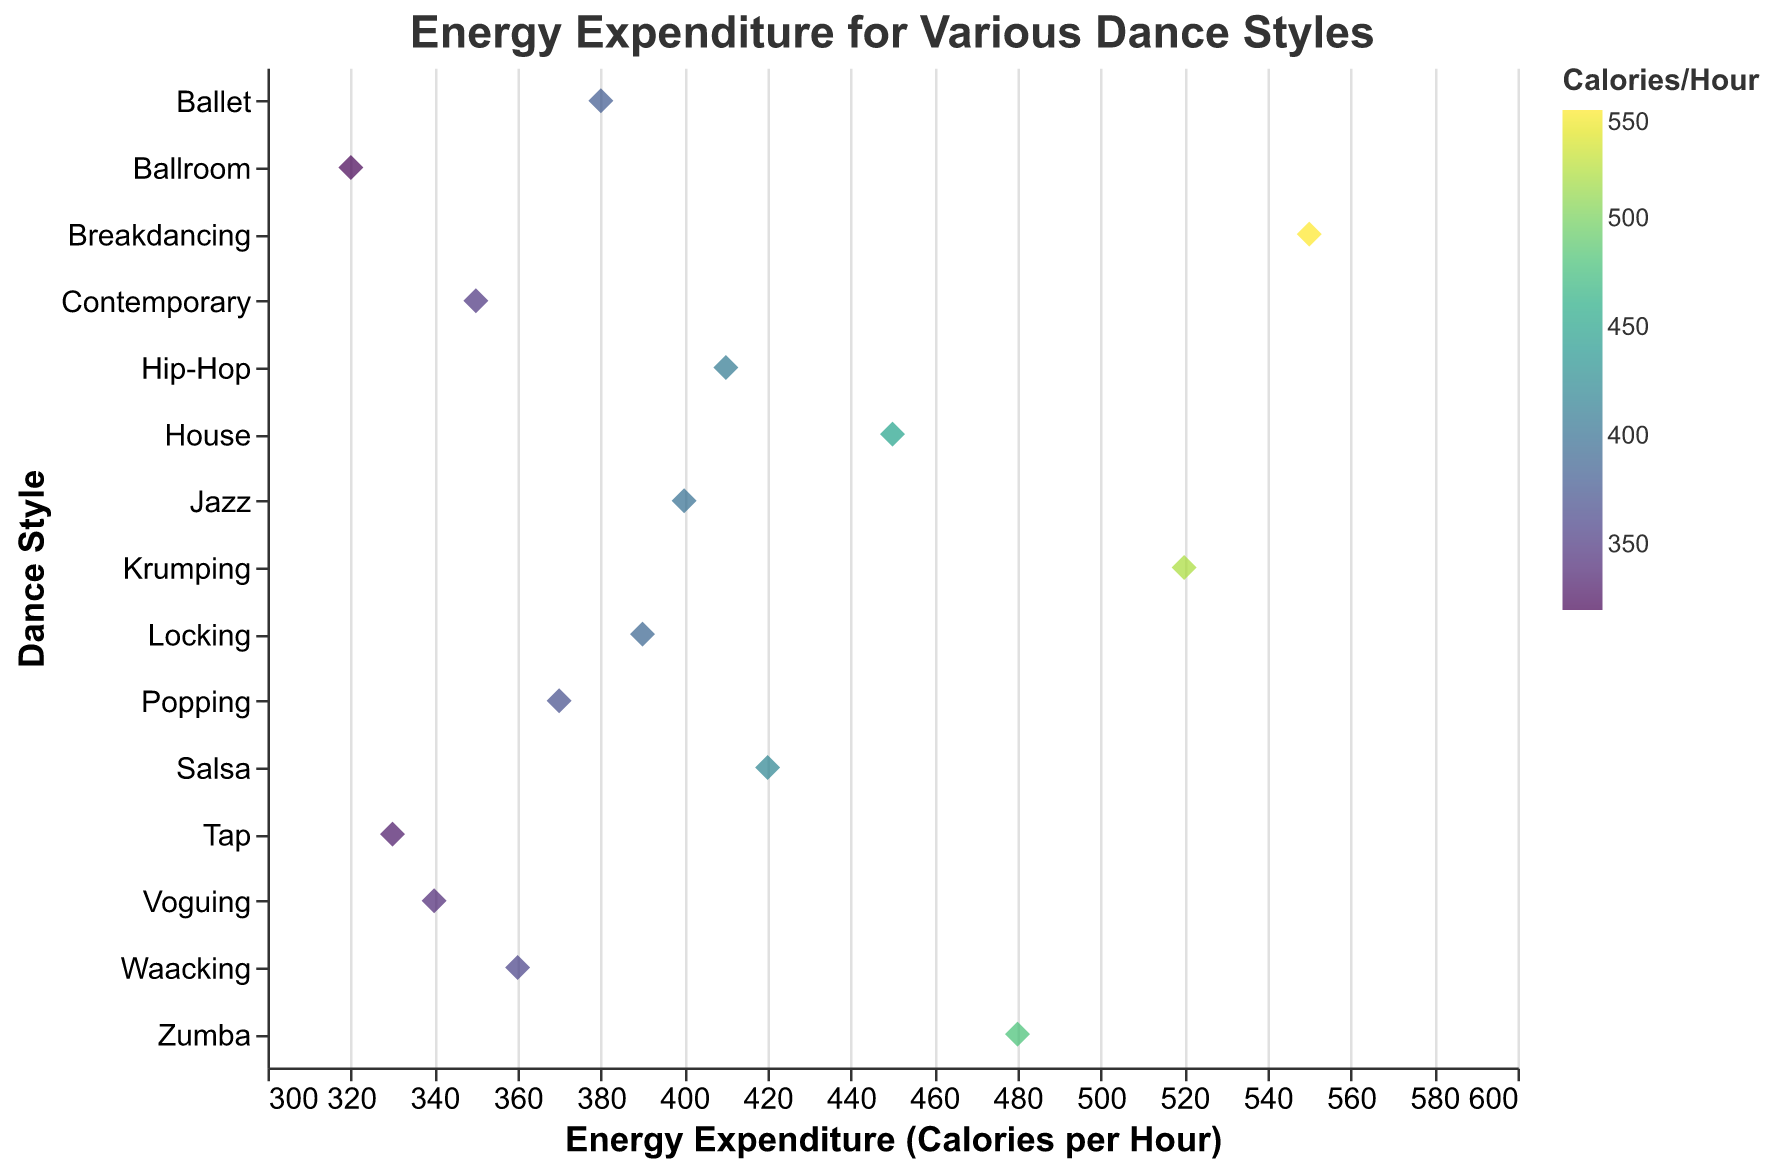What is the title of the plot? The title of the plot is typically found at the top of the figure in a larger font size.
Answer: Energy Expenditure for Various Dance Styles How many data points are represented in the plot? Each dance style corresponds to one data point on the strip plot. By counting the dance styles listed on the y-axis and their respective markers on the plot, we can determine the total number of data points.
Answer: 15 Which dance style has the highest energy expenditure? The highest energy expenditure can be identified by locating the data point farthest to the right on the x-axis.
Answer: Breakdancing What is the energy expenditure for Ballet? The energy expenditure for Ballet can be found by locating "Ballet" on the y-axis and reading its corresponding value on the x-axis.
Answer: 380 calories per hour Which dance style burns more calories, Salsa or Jazz? To compare, find "Salsa" and "Jazz" on the y-axis and check their positions on the x-axis.
Answer: Salsa What is the difference in energy expenditure between Hip-Hop and Tap? Identify the energy expenditure for Hip-Hop and Tap on the x-axis. Subtract the value of Tap from Hip-Hop to find the difference.
Answer: 80 calories per hour What's the average energy expenditure of Hip-Hop, Contemporary, and Ballet? Sum the energy expenditures of Hip-Hop (410), Contemporary (350), and Ballet (380), then divide by 3.
Answer: 380 calories per hour Which dance styles burn between 350 and 400 calories per hour? Check the data points that fall within the 350-400 calorie range on the x-axis.
Answer: Contemporary, Ballet, Jazz, Popping, Waacking What is the color scheme used for representing energy expenditure? The color scheme is specified to indicate the range of calorie expenditure, which can be identified by the gradient or color legend in the plot.
Answer: Viridis Are there more dance styles that burn below or above 400 calories per hour? Count the data points below 400 and compare them to those above 400 on the x-axis.
Answer: Below 400 calories per hour 